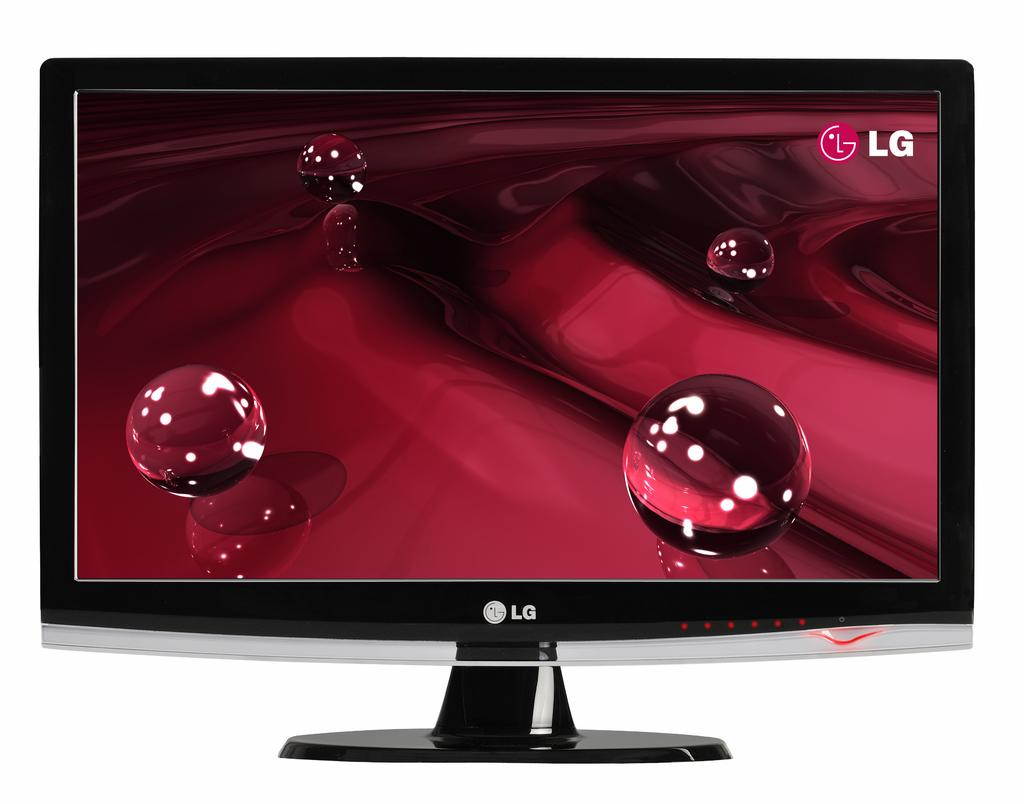<image>
Present a compact description of the photo's key features. LG monitor on the bottom front of the computer. 